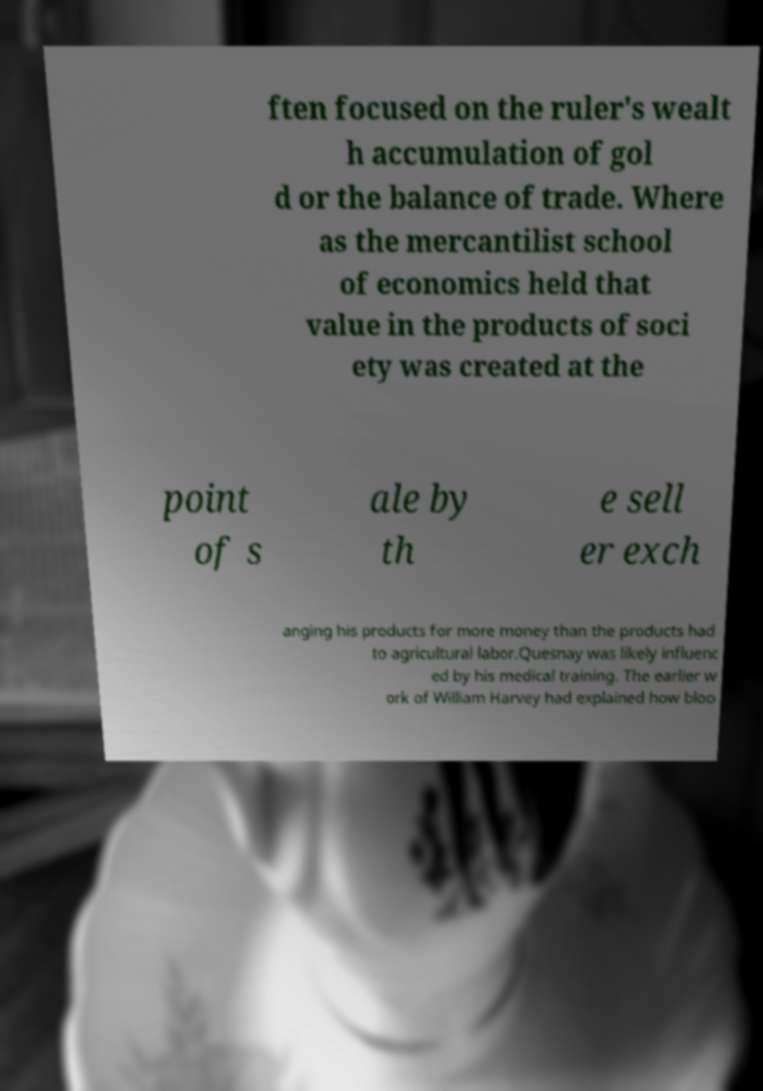Please read and relay the text visible in this image. What does it say? ften focused on the ruler's wealt h accumulation of gol d or the balance of trade. Where as the mercantilist school of economics held that value in the products of soci ety was created at the point of s ale by th e sell er exch anging his products for more money than the products had to agricultural labor.Quesnay was likely influenc ed by his medical training. The earlier w ork of William Harvey had explained how bloo 